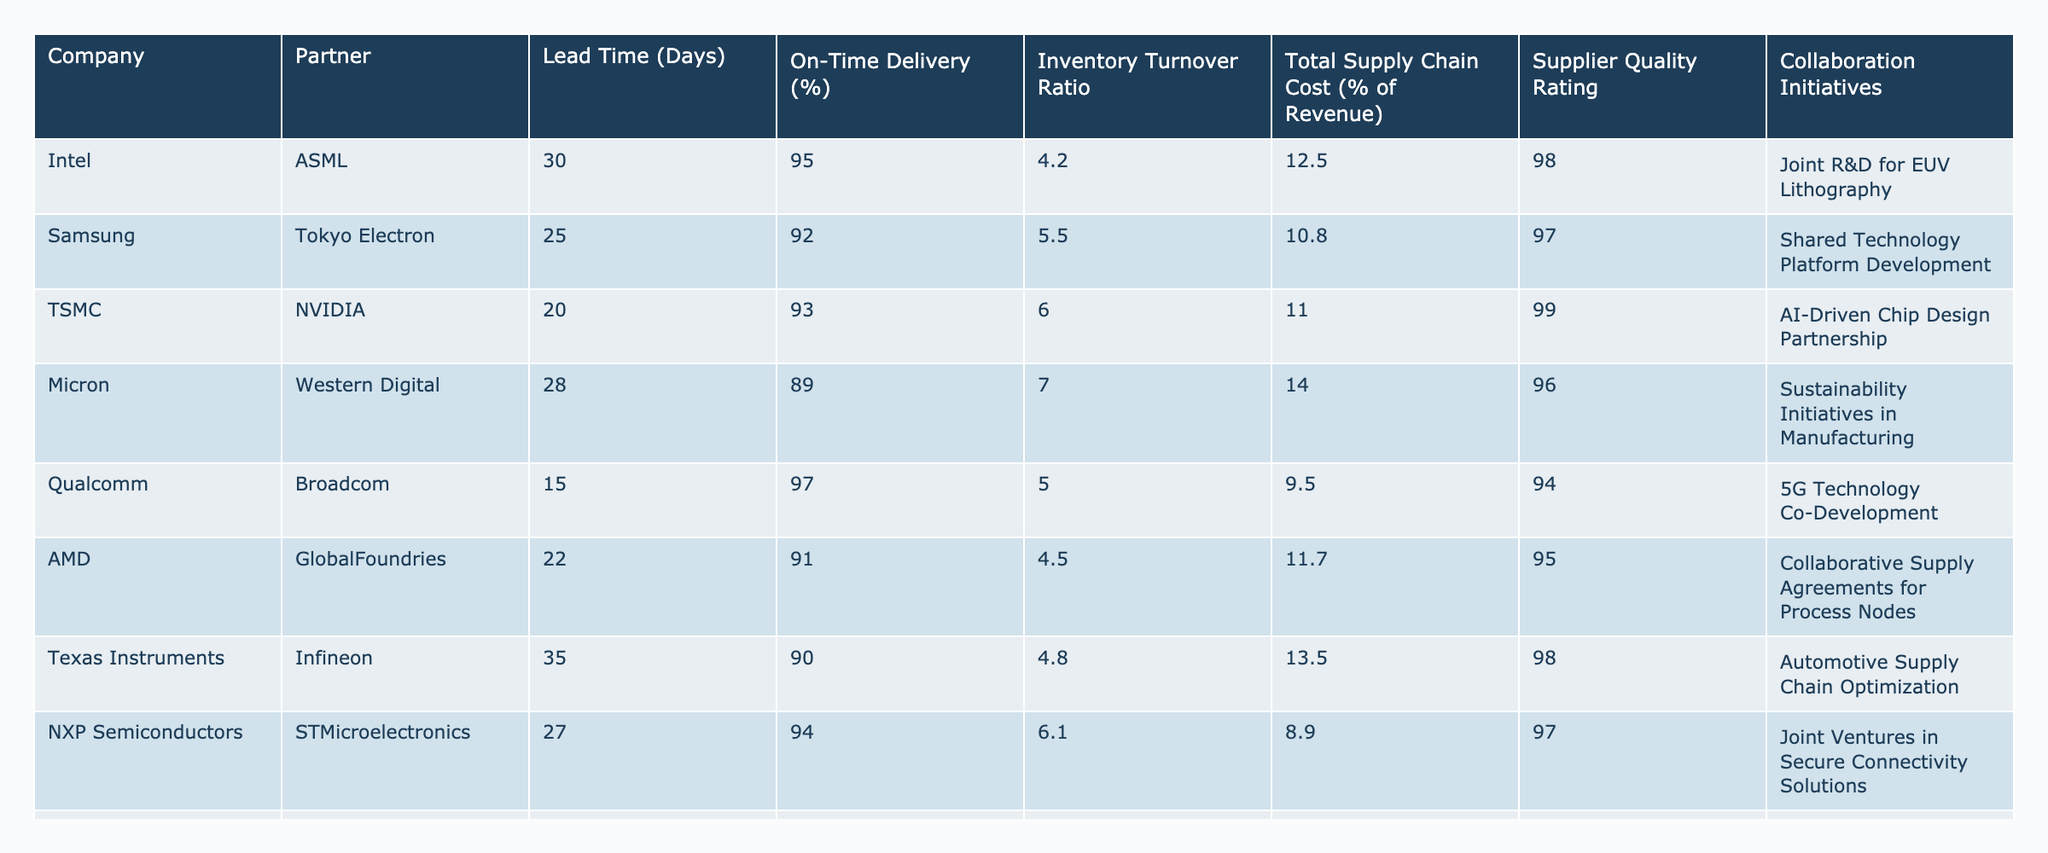What is the lead time for TSMC's partnership with NVIDIA? The table lists TSMC's lead time with NVIDIA as 20 days.
Answer: 20 days Which company has the highest on-time delivery percentage? By reviewing the On-Time Delivery (%) column, Qualcomm has the highest percentage at 97%.
Answer: Qualcomm, 97% What is the average inventory turnover ratio of all companies listed? Adding the inventory turnover ratios (4.2 + 5.5 + 6.0 + 7.0 + 5.0 + 4.5 + 4.8 + 6.1 + 5.6 + 5.9) gives a total of 55.6. Since there are 10 companies, the average is 55.6 / 10 = 5.56.
Answer: 5.56 Is the total supply chain cost of Micron greater than 12% of revenue? Micron’s total supply chain cost is listed as 14.0% of revenue, which is indeed greater than 12%.
Answer: Yes Which partnership has the lowest lead time? Comparing all lead times in the table, Qualcomm's partnership with Broadcom has the lowest lead time of 15 days.
Answer: 15 days Do any companies have a supplier quality rating of 98? Yes, both Intel and Texas Instruments have a supplier quality rating of 98, as indicated in the Supplier Quality Rating column.
Answer: Yes What is the total supply chain cost percentage for AMD's partnership with GlobalFoundries compared to the average? AMD's total supply chain cost is 11.7%. The average cost for all companies is calculated as (12.5 + 10.8 + 11.0 + 14.0 + 9.5 + 11.7 + 13.5 + 8.9 + 12.2 + 10.1) / 10 = 11.17%. 11.7% is greater than the average of 11.17%.
Answer: Greater Which company has the most collaborative initiatives listed? Each company has one collaboration initiative listed, so they all have the same quantity of collaborative initiatives.
Answer: All have one What is the difference in the inventory turnover ratio between the highest and lowest values? The highest inventory turnover ratio is 7.0 (Micron) and the lowest is 4.2 (Intel), calculating the difference: 7.0 - 4.2 = 2.8.
Answer: 2.8 Is it true that NXP Semiconductors has an on-time delivery percentage above 90%? NXP Semiconductors has an on-time delivery percentage of 94%, which is above 90%.
Answer: Yes 